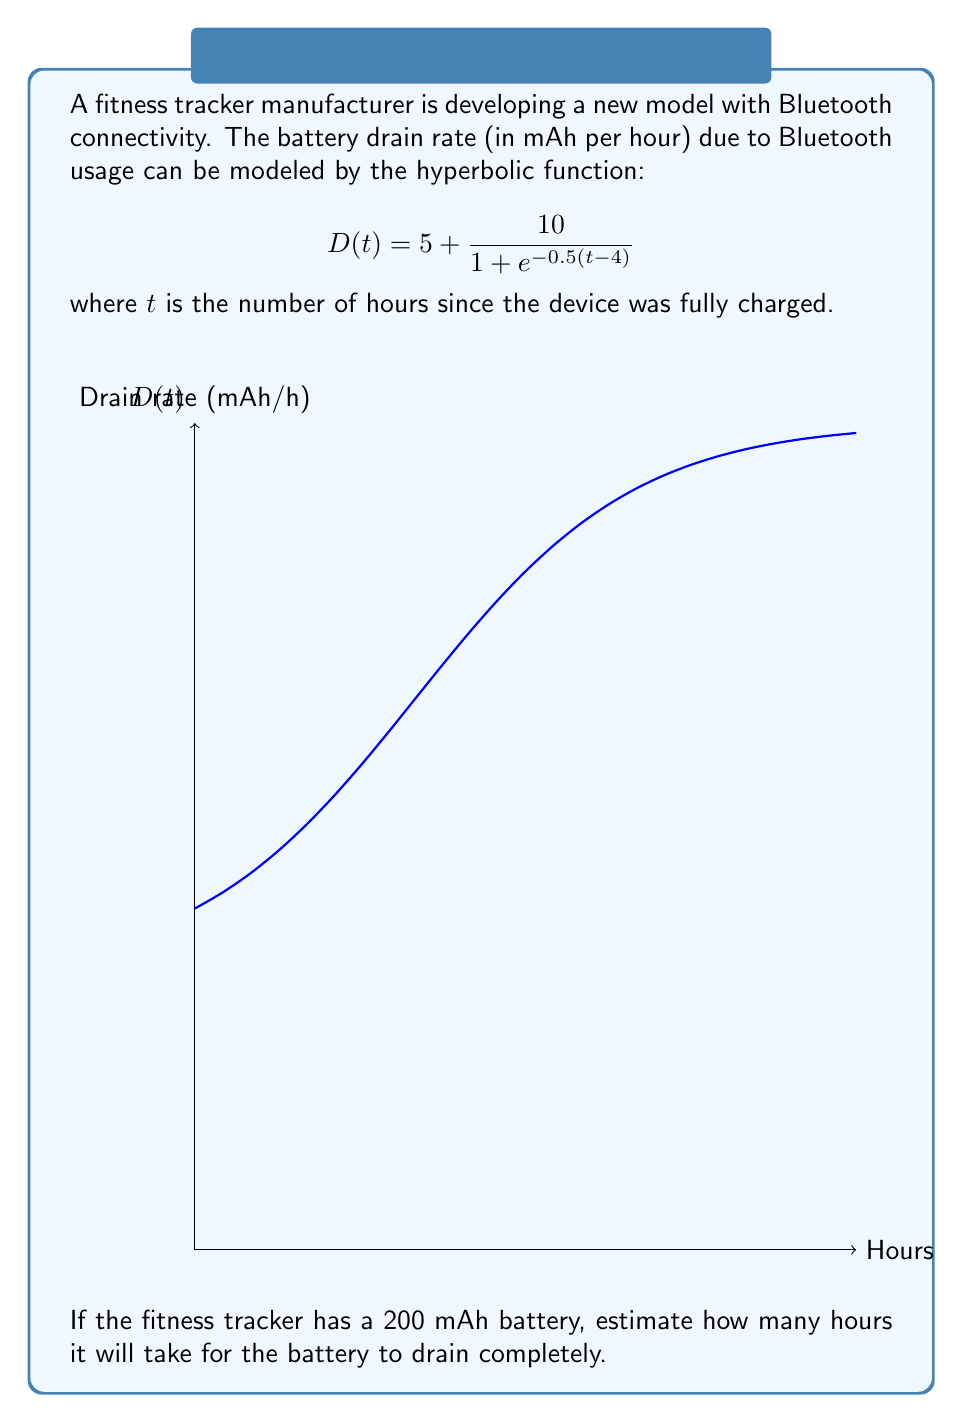Could you help me with this problem? Let's approach this step-by-step:

1) The total battery capacity is 200 mAh. We need to find when the cumulative drain equals this amount.

2) The cumulative drain is the integral of the drain rate function:

   $$\int_0^T D(t) dt = 200$$

   where $T$ is the time we're solving for.

3) Let's break down the integral:

   $$\int_0^T (5 + \frac{10}{1 + e^{-0.5(t-4)}}) dt = 200$$

4) This integral doesn't have a simple closed form. We'll need to use numerical methods or approximation.

5) Let's approximate by using the average drain rate:

   $$D_{avg} = \frac{D(0) + D(T)}{2}$$

6) At $t=0$, $D(0) = 5 + \frac{10}{1 + e^2} \approx 6.27$ mAh/h

7) Let's guess $T \approx 20$ hours:
   
   $D(20) = 5 + \frac{10}{1 + e^{-8}} \approx 14.99$ mAh/h

8) Average drain rate: $D_{avg} \approx \frac{6.27 + 14.99}{2} = 10.63$ mAh/h

9) Time to drain: $T = \frac{200 \text{ mAh}}{10.63 \text{ mAh/h}} \approx 18.82$ hours

10) This is close to our guess, so we'll accept this approximation.
Answer: Approximately 18.8 hours 